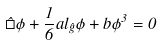<formula> <loc_0><loc_0><loc_500><loc_500>\hat { \square } \phi + \frac { 1 } { 6 } a l _ { \hat { g } } \phi + b \phi ^ { 3 } = 0 \\</formula> 